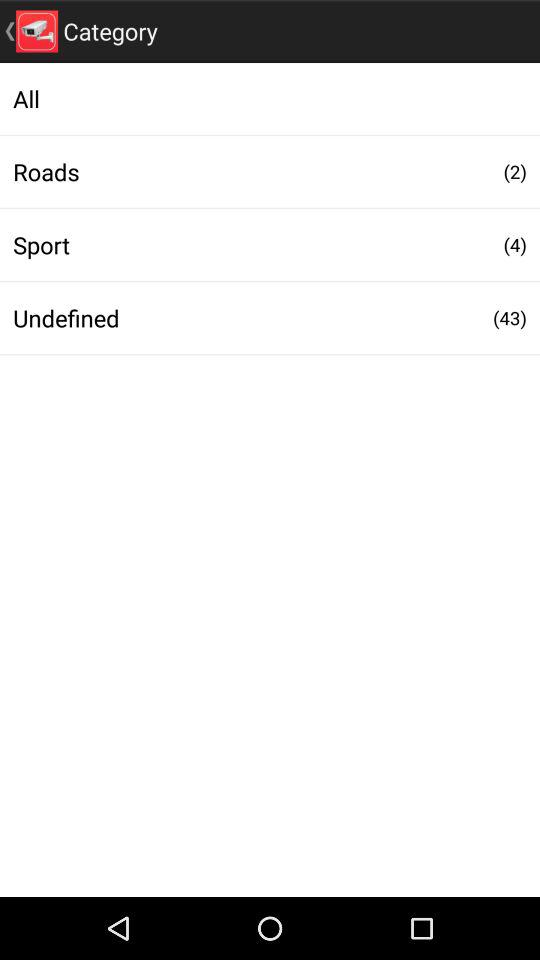How many undefined are shown there? There are 43 undefined. 